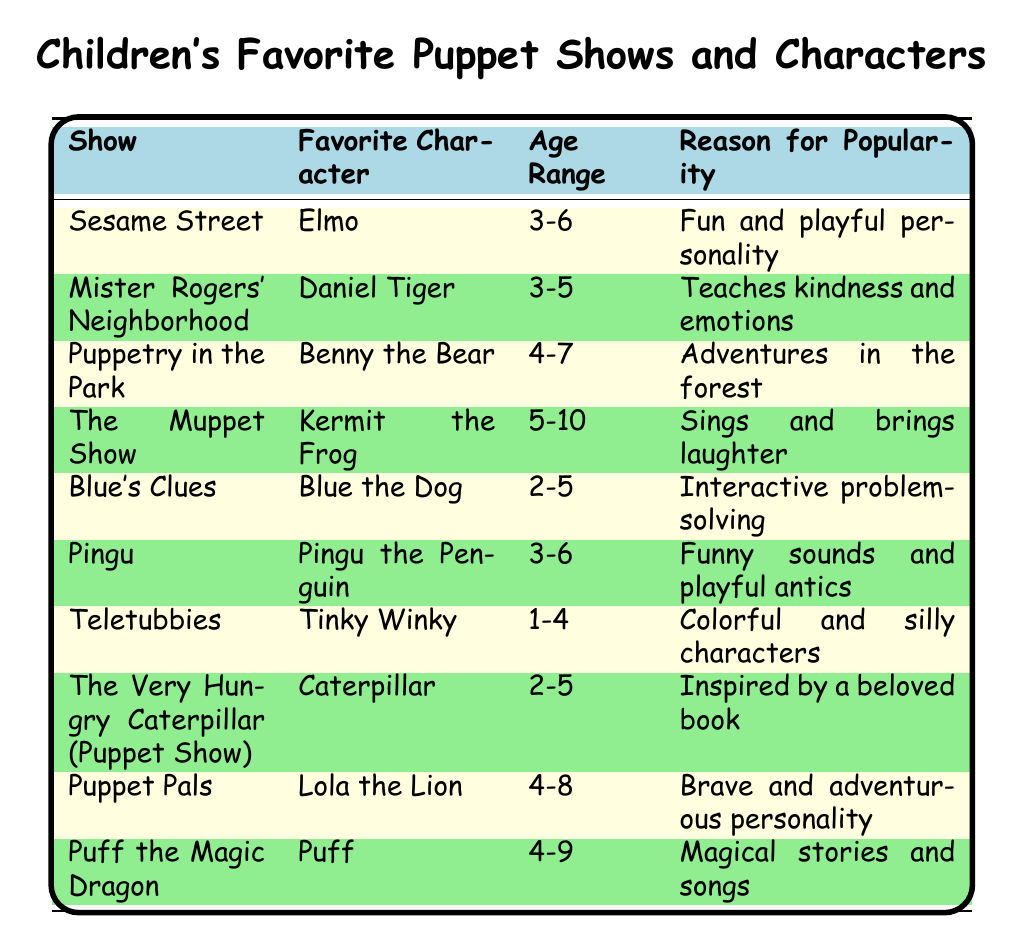What is the favorite character from *Puppetry in the Park*? The character listed under the show *Puppetry in the Park* is *Benny the Bear*.
Answer: *Benny the Bear* Which puppet show has the favorite character *Tinky Winky*? The show with *Tinky Winky* as the favorite character is *Teletubbies*.
Answer: *Teletubbies* What age range does *Puff the Magic Dragon* cater to? The age range for *Puff the Magic Dragon* is 4-9 years old.
Answer: 4-9 True or False: *Elmo* is a favorite character for children aged 3-6. The table indicates that *Elmo* is indeed listed for the age range of 3-6 years, making this statement true.
Answer: True How many shows listed are popular for the age range 2-5? There are three shows that cater to the age range of 2-5: *Blue's Clues*, *The Very Hungry Caterpillar (Puppet Show)*, and *Teletubbies*.
Answer: 3 Which puppet show teaches kindness and emotions? The show that teaches kindness and emotions is *Mister Rogers' Neighborhood*, with *Daniel Tiger* as the favorite character.
Answer: *Mister Rogers' Neighborhood* What is the reason for the popularity of *Kermit the Frog*? The reason provided for *Kermit the Frog*'s popularity is that he "sings and brings laughter."
Answer: Sings and brings laughter How many characters' favorite shows involve animals? The characters whose favorite shows involve animals are *Blue the Dog*, *Pingu the Penguin*, and *Lola the Lion* which totals three.
Answer: 3 Which show has the character with the most adventurous personality? Both *Lola the Lion* from *Puppet Pals* and *Benny the Bear* have adventurous personalities, but *Lola the Lion* is specifically highlighted as brave and adventurous.
Answer: *Puppet Pals* What is the common reason for popularity among shows geared towards ages 4-6? The shows geared towards ages 4-6, including *Puppetry in the Park*, *Pingu*, and *Sesame Street*, commonly emphasize fun, adventure, and playful antics.
Answer: Fun and playful antics 